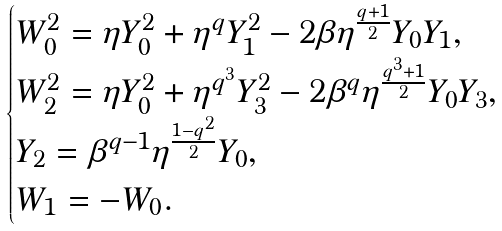Convert formula to latex. <formula><loc_0><loc_0><loc_500><loc_500>\begin{cases} W _ { 0 } ^ { 2 } = \eta Y _ { 0 } ^ { 2 } + \eta ^ { q } Y _ { 1 } ^ { 2 } - 2 \beta \eta ^ { \frac { q + 1 } { 2 } } Y _ { 0 } Y _ { 1 } , \\ W _ { 2 } ^ { 2 } = \eta Y _ { 0 } ^ { 2 } + \eta ^ { q ^ { 3 } } Y _ { 3 } ^ { 2 } - 2 \beta ^ { q } \eta ^ { \frac { q ^ { 3 } + 1 } { 2 } } Y _ { 0 } Y _ { 3 } , \\ Y _ { 2 } = \beta ^ { q - 1 } \eta ^ { \frac { 1 - q ^ { 2 } } { 2 } } Y _ { 0 } , \\ W _ { 1 } = - W _ { 0 } . \\ \end{cases}</formula> 